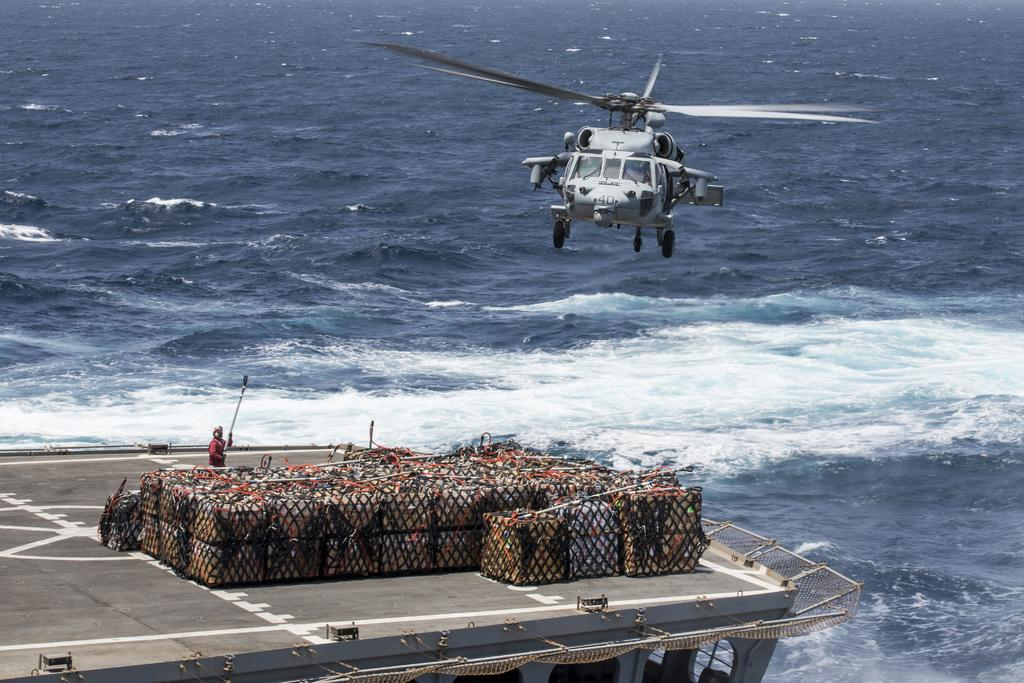What is located in the foreground of the image? There is a boat, boxes, and a person in the foreground of the image. What type of vehicle is visible in the image? There is a helicopter visible in the image. What can be seen in the background of the image? The background of the image includes the ocean. When was the image taken? The image was taken during the day. What type of friction can be observed between the boat and the water in the image? There is no specific type of friction mentioned or observable in the image; it simply shows a boat in the water. Can you tell me how many trucks are present in the image? There are no trucks present in the image. 